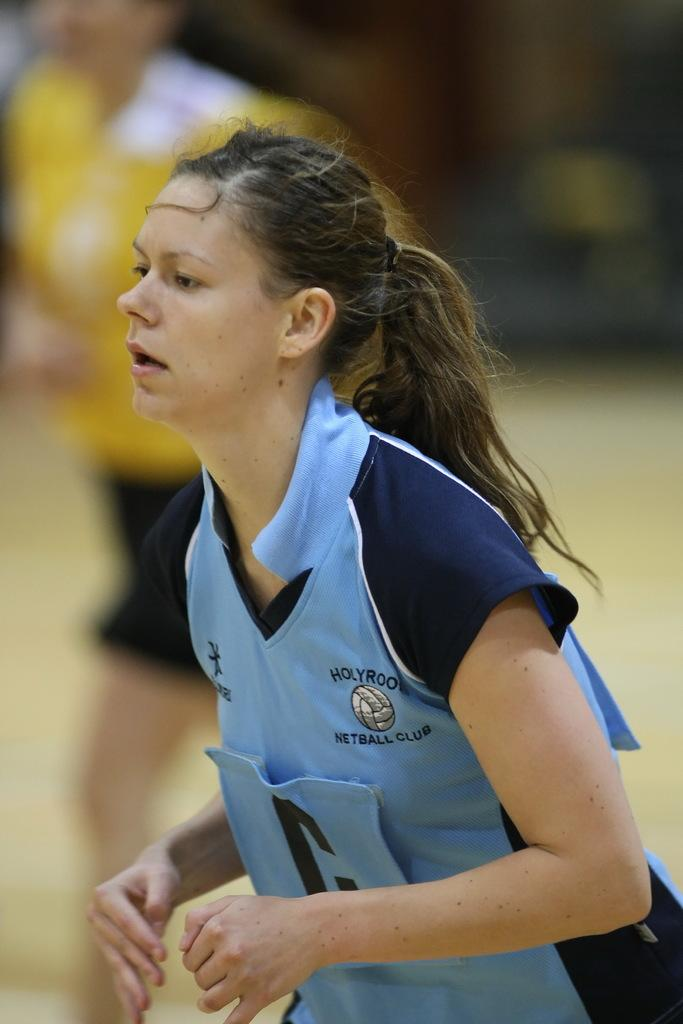Provide a one-sentence caption for the provided image. The girl is part of the netball club at her school. 